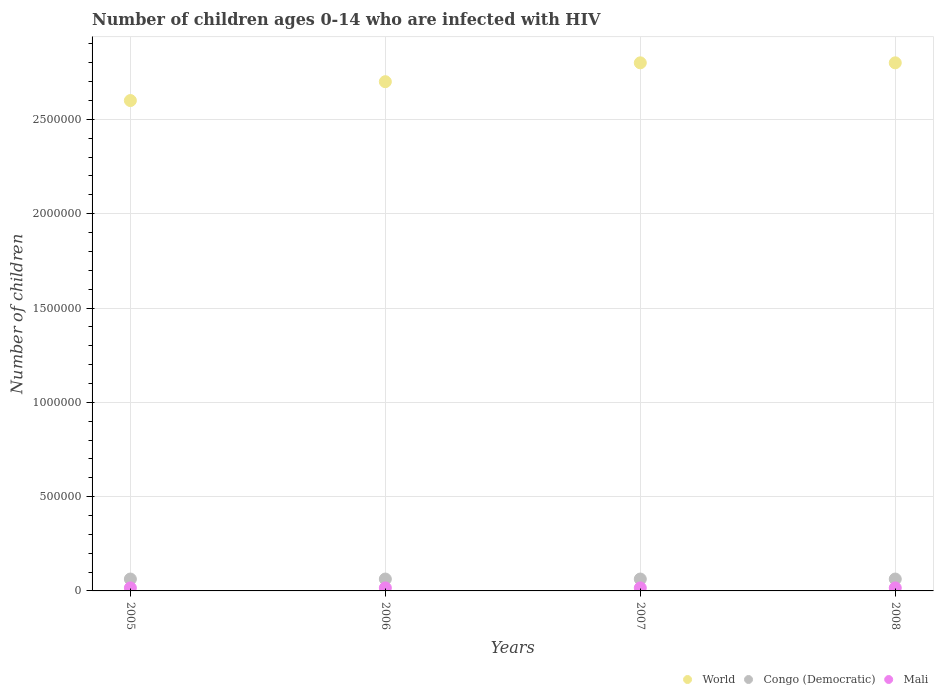How many different coloured dotlines are there?
Offer a terse response. 3. Is the number of dotlines equal to the number of legend labels?
Offer a terse response. Yes. What is the number of HIV infected children in Mali in 2006?
Offer a terse response. 1.60e+04. Across all years, what is the maximum number of HIV infected children in Congo (Democratic)?
Your response must be concise. 6.30e+04. Across all years, what is the minimum number of HIV infected children in World?
Your answer should be very brief. 2.60e+06. In which year was the number of HIV infected children in Mali maximum?
Your answer should be compact. 2005. What is the total number of HIV infected children in Mali in the graph?
Your answer should be very brief. 6.40e+04. What is the difference between the number of HIV infected children in World in 2005 and that in 2008?
Your answer should be compact. -2.00e+05. What is the difference between the number of HIV infected children in World in 2008 and the number of HIV infected children in Mali in 2007?
Offer a very short reply. 2.78e+06. What is the average number of HIV infected children in Mali per year?
Make the answer very short. 1.60e+04. In the year 2008, what is the difference between the number of HIV infected children in Congo (Democratic) and number of HIV infected children in World?
Ensure brevity in your answer.  -2.74e+06. What is the ratio of the number of HIV infected children in Congo (Democratic) in 2006 to that in 2007?
Your answer should be compact. 1. Is the difference between the number of HIV infected children in Congo (Democratic) in 2006 and 2007 greater than the difference between the number of HIV infected children in World in 2006 and 2007?
Make the answer very short. Yes. What is the difference between the highest and the second highest number of HIV infected children in World?
Offer a terse response. 0. In how many years, is the number of HIV infected children in World greater than the average number of HIV infected children in World taken over all years?
Offer a terse response. 2. Is the sum of the number of HIV infected children in Mali in 2005 and 2006 greater than the maximum number of HIV infected children in Congo (Democratic) across all years?
Your answer should be very brief. No. How many dotlines are there?
Provide a succinct answer. 3. Does the graph contain any zero values?
Provide a succinct answer. No. Does the graph contain grids?
Provide a succinct answer. Yes. Where does the legend appear in the graph?
Make the answer very short. Bottom right. How are the legend labels stacked?
Your response must be concise. Horizontal. What is the title of the graph?
Offer a very short reply. Number of children ages 0-14 who are infected with HIV. What is the label or title of the X-axis?
Your answer should be compact. Years. What is the label or title of the Y-axis?
Offer a very short reply. Number of children. What is the Number of children of World in 2005?
Provide a succinct answer. 2.60e+06. What is the Number of children of Congo (Democratic) in 2005?
Give a very brief answer. 6.30e+04. What is the Number of children of Mali in 2005?
Keep it short and to the point. 1.60e+04. What is the Number of children in World in 2006?
Your response must be concise. 2.70e+06. What is the Number of children of Congo (Democratic) in 2006?
Provide a succinct answer. 6.30e+04. What is the Number of children of Mali in 2006?
Your answer should be very brief. 1.60e+04. What is the Number of children in World in 2007?
Make the answer very short. 2.80e+06. What is the Number of children of Congo (Democratic) in 2007?
Give a very brief answer. 6.30e+04. What is the Number of children of Mali in 2007?
Your response must be concise. 1.60e+04. What is the Number of children of World in 2008?
Offer a very short reply. 2.80e+06. What is the Number of children of Congo (Democratic) in 2008?
Provide a succinct answer. 6.30e+04. What is the Number of children of Mali in 2008?
Your answer should be very brief. 1.60e+04. Across all years, what is the maximum Number of children of World?
Make the answer very short. 2.80e+06. Across all years, what is the maximum Number of children of Congo (Democratic)?
Your answer should be very brief. 6.30e+04. Across all years, what is the maximum Number of children of Mali?
Keep it short and to the point. 1.60e+04. Across all years, what is the minimum Number of children in World?
Offer a very short reply. 2.60e+06. Across all years, what is the minimum Number of children in Congo (Democratic)?
Give a very brief answer. 6.30e+04. Across all years, what is the minimum Number of children in Mali?
Make the answer very short. 1.60e+04. What is the total Number of children in World in the graph?
Your answer should be compact. 1.09e+07. What is the total Number of children in Congo (Democratic) in the graph?
Your answer should be very brief. 2.52e+05. What is the total Number of children of Mali in the graph?
Your answer should be very brief. 6.40e+04. What is the difference between the Number of children of Mali in 2005 and that in 2006?
Offer a terse response. 0. What is the difference between the Number of children in Congo (Democratic) in 2005 and that in 2007?
Keep it short and to the point. 0. What is the difference between the Number of children in World in 2005 and that in 2008?
Your response must be concise. -2.00e+05. What is the difference between the Number of children of Congo (Democratic) in 2005 and that in 2008?
Give a very brief answer. 0. What is the difference between the Number of children of Congo (Democratic) in 2006 and that in 2007?
Your answer should be compact. 0. What is the difference between the Number of children in Congo (Democratic) in 2006 and that in 2008?
Your answer should be compact. 0. What is the difference between the Number of children in Congo (Democratic) in 2007 and that in 2008?
Keep it short and to the point. 0. What is the difference between the Number of children of World in 2005 and the Number of children of Congo (Democratic) in 2006?
Keep it short and to the point. 2.54e+06. What is the difference between the Number of children of World in 2005 and the Number of children of Mali in 2006?
Your answer should be very brief. 2.58e+06. What is the difference between the Number of children in Congo (Democratic) in 2005 and the Number of children in Mali in 2006?
Keep it short and to the point. 4.70e+04. What is the difference between the Number of children of World in 2005 and the Number of children of Congo (Democratic) in 2007?
Make the answer very short. 2.54e+06. What is the difference between the Number of children of World in 2005 and the Number of children of Mali in 2007?
Your answer should be very brief. 2.58e+06. What is the difference between the Number of children of Congo (Democratic) in 2005 and the Number of children of Mali in 2007?
Keep it short and to the point. 4.70e+04. What is the difference between the Number of children in World in 2005 and the Number of children in Congo (Democratic) in 2008?
Offer a terse response. 2.54e+06. What is the difference between the Number of children of World in 2005 and the Number of children of Mali in 2008?
Your response must be concise. 2.58e+06. What is the difference between the Number of children of Congo (Democratic) in 2005 and the Number of children of Mali in 2008?
Offer a very short reply. 4.70e+04. What is the difference between the Number of children in World in 2006 and the Number of children in Congo (Democratic) in 2007?
Offer a terse response. 2.64e+06. What is the difference between the Number of children of World in 2006 and the Number of children of Mali in 2007?
Offer a terse response. 2.68e+06. What is the difference between the Number of children of Congo (Democratic) in 2006 and the Number of children of Mali in 2007?
Your answer should be very brief. 4.70e+04. What is the difference between the Number of children in World in 2006 and the Number of children in Congo (Democratic) in 2008?
Keep it short and to the point. 2.64e+06. What is the difference between the Number of children of World in 2006 and the Number of children of Mali in 2008?
Provide a short and direct response. 2.68e+06. What is the difference between the Number of children of Congo (Democratic) in 2006 and the Number of children of Mali in 2008?
Your answer should be very brief. 4.70e+04. What is the difference between the Number of children of World in 2007 and the Number of children of Congo (Democratic) in 2008?
Provide a short and direct response. 2.74e+06. What is the difference between the Number of children of World in 2007 and the Number of children of Mali in 2008?
Your response must be concise. 2.78e+06. What is the difference between the Number of children of Congo (Democratic) in 2007 and the Number of children of Mali in 2008?
Make the answer very short. 4.70e+04. What is the average Number of children in World per year?
Your answer should be very brief. 2.72e+06. What is the average Number of children of Congo (Democratic) per year?
Your answer should be very brief. 6.30e+04. What is the average Number of children of Mali per year?
Ensure brevity in your answer.  1.60e+04. In the year 2005, what is the difference between the Number of children in World and Number of children in Congo (Democratic)?
Your answer should be compact. 2.54e+06. In the year 2005, what is the difference between the Number of children of World and Number of children of Mali?
Provide a succinct answer. 2.58e+06. In the year 2005, what is the difference between the Number of children of Congo (Democratic) and Number of children of Mali?
Offer a terse response. 4.70e+04. In the year 2006, what is the difference between the Number of children of World and Number of children of Congo (Democratic)?
Keep it short and to the point. 2.64e+06. In the year 2006, what is the difference between the Number of children of World and Number of children of Mali?
Provide a succinct answer. 2.68e+06. In the year 2006, what is the difference between the Number of children of Congo (Democratic) and Number of children of Mali?
Offer a terse response. 4.70e+04. In the year 2007, what is the difference between the Number of children of World and Number of children of Congo (Democratic)?
Offer a very short reply. 2.74e+06. In the year 2007, what is the difference between the Number of children in World and Number of children in Mali?
Offer a very short reply. 2.78e+06. In the year 2007, what is the difference between the Number of children in Congo (Democratic) and Number of children in Mali?
Offer a very short reply. 4.70e+04. In the year 2008, what is the difference between the Number of children in World and Number of children in Congo (Democratic)?
Your answer should be very brief. 2.74e+06. In the year 2008, what is the difference between the Number of children in World and Number of children in Mali?
Your answer should be very brief. 2.78e+06. In the year 2008, what is the difference between the Number of children of Congo (Democratic) and Number of children of Mali?
Provide a succinct answer. 4.70e+04. What is the ratio of the Number of children of World in 2005 to that in 2006?
Provide a succinct answer. 0.96. What is the ratio of the Number of children in Congo (Democratic) in 2005 to that in 2006?
Provide a succinct answer. 1. What is the ratio of the Number of children in Mali in 2005 to that in 2006?
Your response must be concise. 1. What is the ratio of the Number of children of Mali in 2005 to that in 2007?
Offer a terse response. 1. What is the ratio of the Number of children in Congo (Democratic) in 2006 to that in 2007?
Your response must be concise. 1. What is the ratio of the Number of children of Mali in 2006 to that in 2007?
Provide a short and direct response. 1. What is the ratio of the Number of children of World in 2007 to that in 2008?
Give a very brief answer. 1. What is the ratio of the Number of children in Congo (Democratic) in 2007 to that in 2008?
Your answer should be compact. 1. What is the difference between the highest and the second highest Number of children in Mali?
Offer a terse response. 0. 